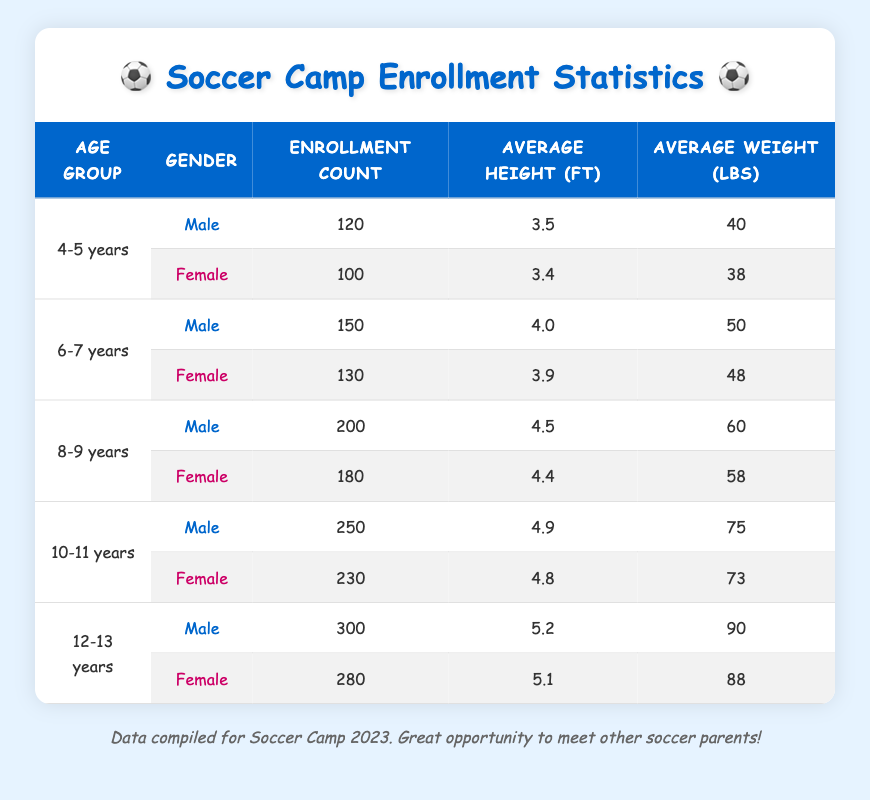What is the enrollment count for males aged 4-5 years? According to the table, the enrollment count for males in the 4-5 years age group is listed directly under that category. It shows a figure of 120.
Answer: 120 What is the average weight of females in the 10-11 years age group? In the table, the average weight of females in the 10-11 years group is stated, which is 73 pounds.
Answer: 73 Which age group has the highest overall enrollment count? To determine the highest overall enrollment, each age group's male and female counts are summed. For example, 4-5 years total is 220, 6-7 years is 280, 8-9 years is 380, 10-11 years is 480, and 12-13 years is 580. The highest is the 12-13 years with a total of 580.
Answer: 12-13 years Is the average height of males in the 6-7 years group greater than that of females in the same age group? The average height for males aged 6-7 years is 4.0 feet, and for females in the same group, it is 3.9 feet. Comparing these values shows that 4.0 is greater than 3.9, making the statement true.
Answer: Yes What is the total enrollment count for all age groups combined for females? To find the total for females, add the enrollment counts from the female presentations across age groups: 100 (4-5) + 130 (6-7) + 180 (8-9) + 230 (10-11) + 280 (12-13) = 1020 overall.
Answer: 1020 How many more males are enrolled in the 10-11 years group compared to the 8-9 years group? The enrollment for 10-11 years males is 250, and for 8-9 years males, it is 200. To find the difference, subtract 200 from 250, resulting in 50 more enrollments in the 10-11 years group.
Answer: 50 What is the average height of the entire 12-13 years age group, combining both genders? To find the average height for the 12-13 years group, sum the heights (5.2 for males + 5.1 for females) and divide by 2: (5.2 + 5.1) / 2 = 5.15.
Answer: 5.15 Is the enrollment count for females in the 8-9 years group lower than that of males in the same age group? In the table, the enrollment count for males in the 8-9 years age group is 200, while for females it is 180. Since 180 is less than 200, the statement is true.
Answer: Yes What is the combined average weight of all the males in the soccer camp? To find the combined average weight of all males, sum the males' weights: 40 (4-5) + 50 (6-7) + 60 (8-9) + 75 (10-11) + 90 (12-13) = 315. Next, divide by the number of male age groups (5): 315 / 5 = 63.
Answer: 63 